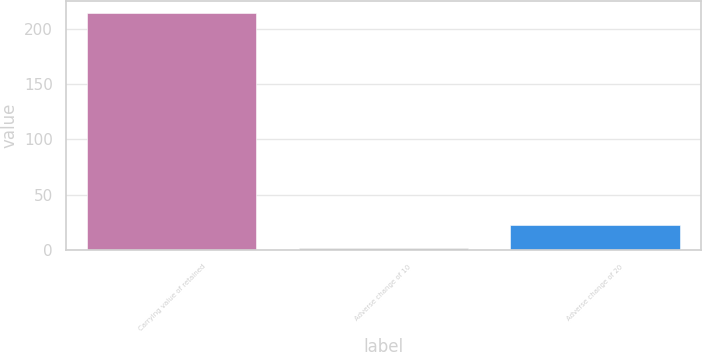<chart> <loc_0><loc_0><loc_500><loc_500><bar_chart><fcel>Carrying value of retained<fcel>Adverse change of 10<fcel>Adverse change of 20<nl><fcel>214<fcel>2<fcel>23.2<nl></chart> 